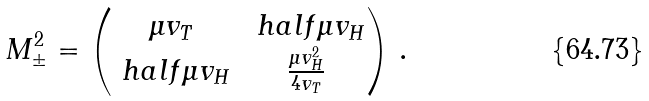Convert formula to latex. <formula><loc_0><loc_0><loc_500><loc_500>M _ { \pm } ^ { 2 } = \begin{pmatrix} \mu v _ { T } & \ h a l f \mu v _ { H } \\ \ h a l f \mu v _ { H } & \frac { \mu v _ { H } ^ { 2 } } { 4 v _ { T } } \end{pmatrix} \, .</formula> 